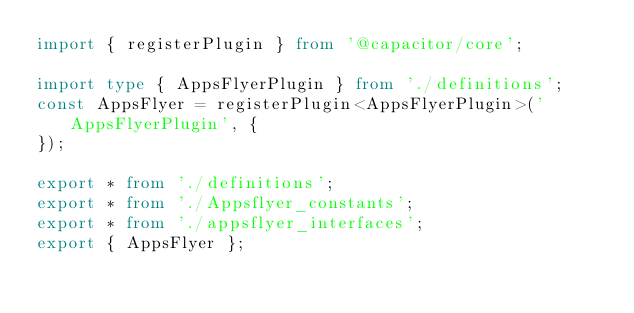<code> <loc_0><loc_0><loc_500><loc_500><_TypeScript_>import { registerPlugin } from '@capacitor/core';

import type { AppsFlyerPlugin } from './definitions';
const AppsFlyer = registerPlugin<AppsFlyerPlugin>('AppsFlyerPlugin', {
});

export * from './definitions';
export * from './Appsflyer_constants';
export * from './appsflyer_interfaces';
export { AppsFlyer };
</code> 